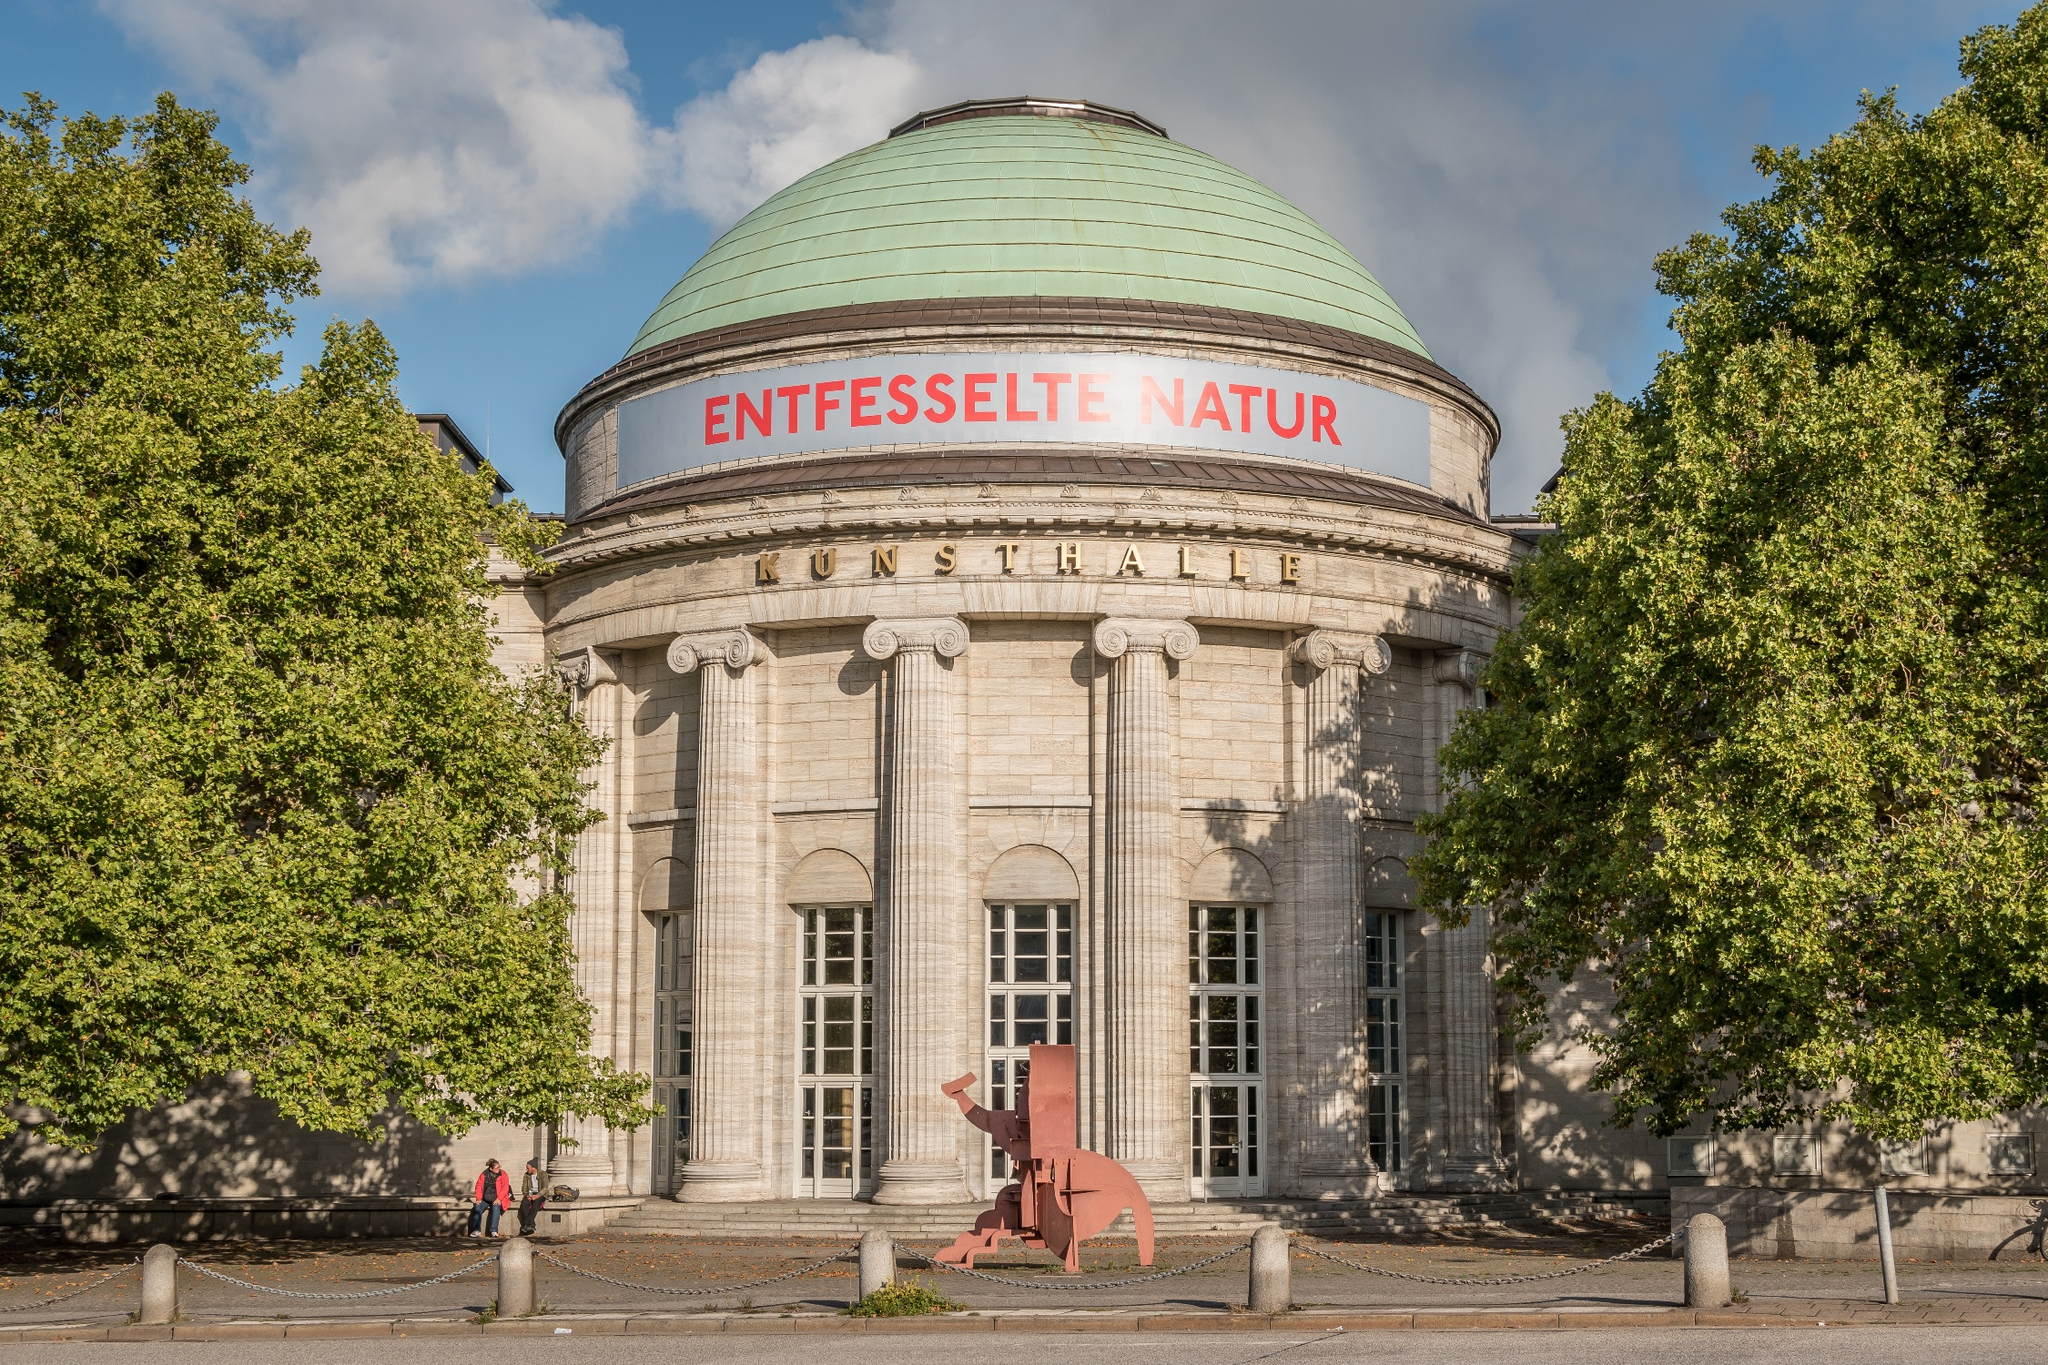What can you say about the sculpture at the entrance? The sculpture at the entrance of the Kunsthalle Hamburg is a striking piece with a modern abstract design. Its bold red color stands in vivid contrast against the neoclassical backdrop of the museum. The dynamic form of the sculpture suggests movement and energy, possibly symbolizing creativity and the vibrant spirit of art that the museum embraces. Its location at the entrance serves as an inviting visual statement, drawing visitors into the artistic journey that awaits inside. Can you imagine what the artist might have intended to convey through this sculpture? The artist might have intended to convey a sense of bold, dynamic energy through this sculpture. Its abstract form and striking color could symbolize the imagination and creativity that are central to the experience of art. The sculpture’s placement at the museum’s entrance might suggest the idea of art as a gateway to new perspectives and emotional experiences. Its modern aesthetic contrasts with the neoclassical architecture, highlighting the progressive nature of contemporary art within a historical setting. What if this sculpture could talk? What do you think it would say? If the sculpture could talk, it might proclaim, 'Welcome to a world of imagination and wonder! Within these walls, art comes alive, transcending time and space. I stand here as a guardian of creativity, a testament to the power of human expression. Step closer, let your mind wander, and immerse yourself in the uncharted territories of artistic brilliance. Embrace the vibrant energy I embody, for it is only a glimpse of the treasures that lie within.' 